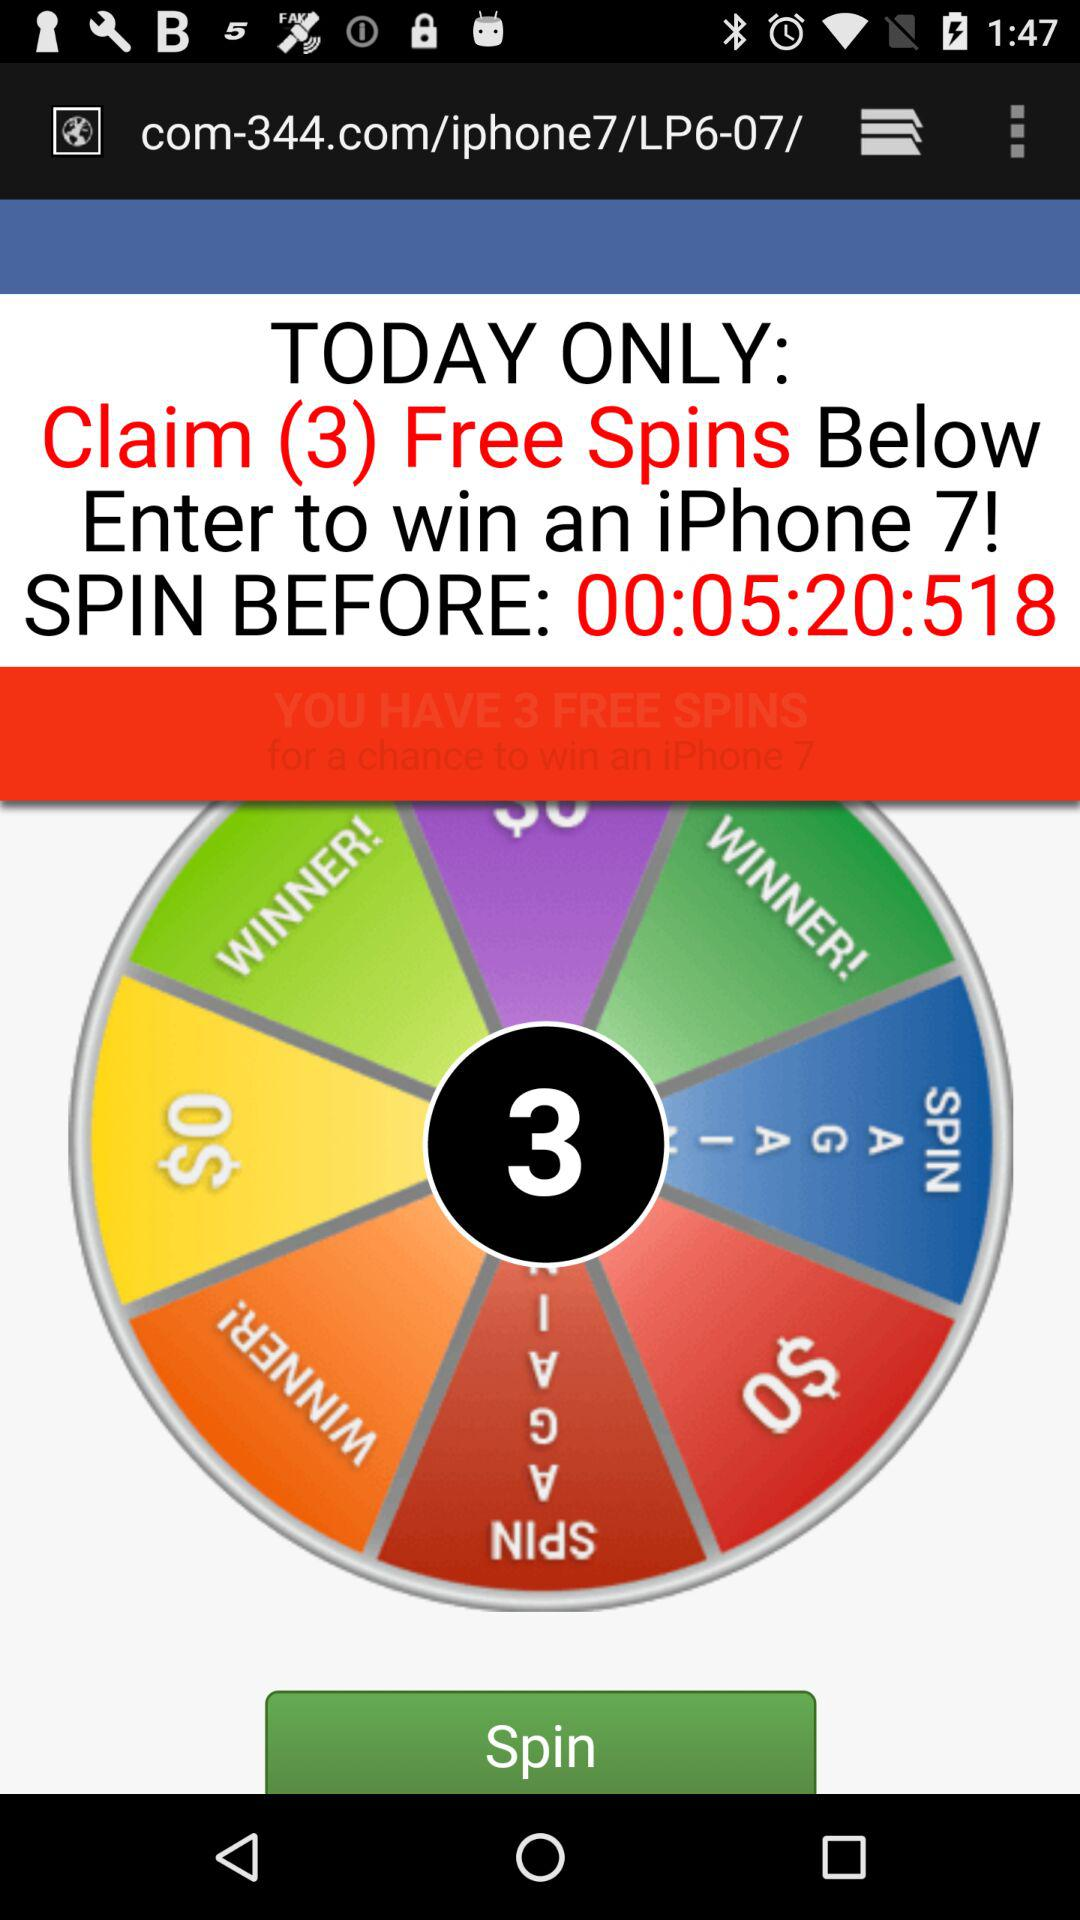What do I do to win an iPhone?
When the provided information is insufficient, respond with <no answer>. <no answer> 